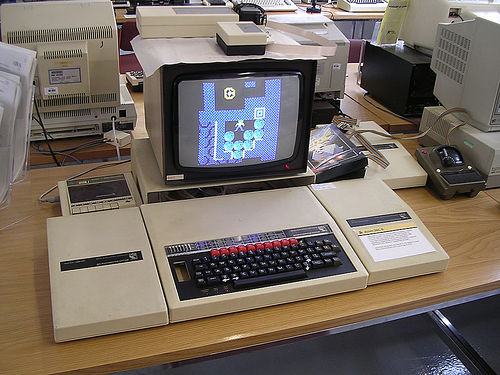<image>
Can you confirm if the monitor is next to the monitor? Yes. The monitor is positioned adjacent to the monitor, located nearby in the same general area. 